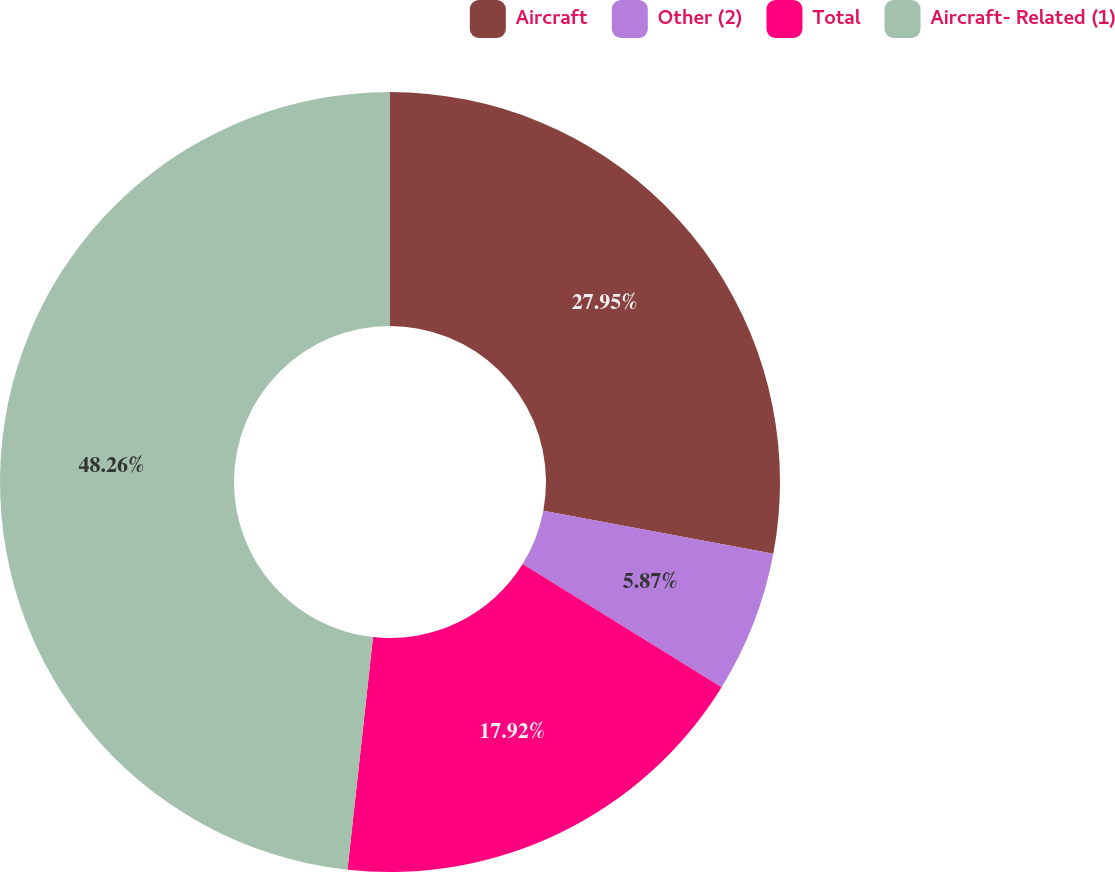<chart> <loc_0><loc_0><loc_500><loc_500><pie_chart><fcel>Aircraft<fcel>Other (2)<fcel>Total<fcel>Aircraft- Related (1)<nl><fcel>27.95%<fcel>5.87%<fcel>17.92%<fcel>48.26%<nl></chart> 